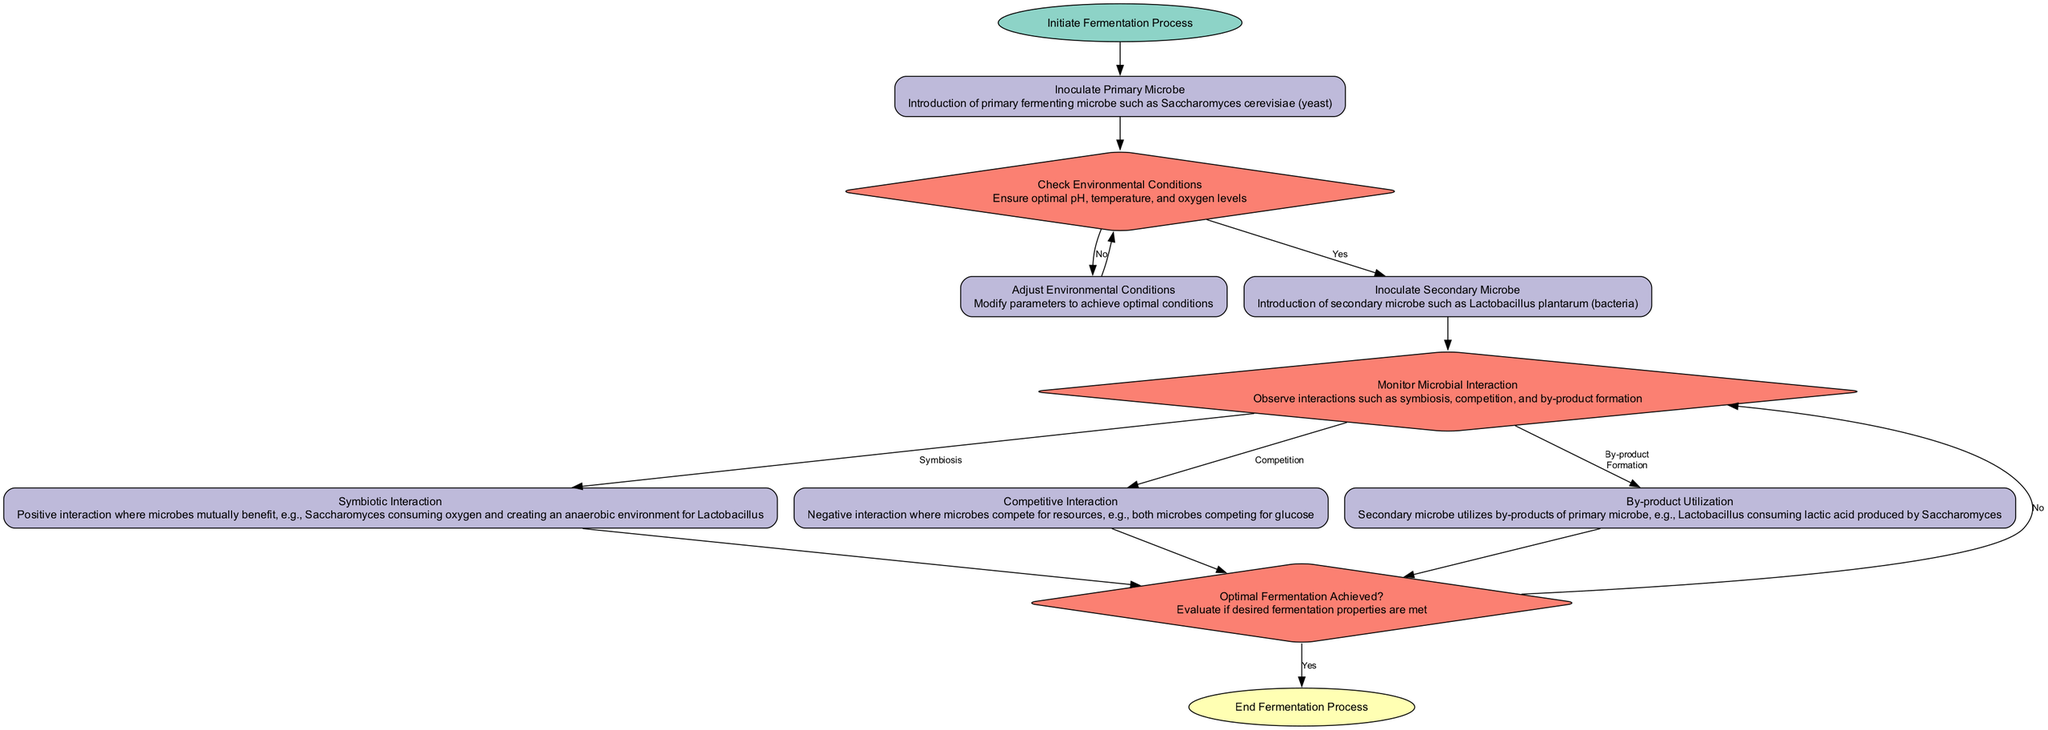What is the first step in the fermentation process? The diagram indicates that the fermentation process begins with the node titled "Initiate Fermentation Process," which serves as the starting point.
Answer: Initiate Fermentation Process How many decision points are in the diagram? By examining the diagram, there are three decision nodes: "Check Environmental Conditions," "Monitor Microbial Interaction," and "Optimal Fermentation Achieved?" Therefore, the total is three decision points.
Answer: 3 What type of interaction occurs during the positive interaction phase? According to the diagram, the positive interaction is specifically referred to as "Symbiotic Interaction," which indicates the nature of the positive relationships among microbial species involved in co-culture fermentation.
Answer: Symbiotic Interaction What follows after the "Inoculate Secondary Microbe"? The flow from the "Inoculate Secondary Microbe" leads to the next process: "Monitor Microbial Interaction," thus establishing a sequential relationship in the steps of fermentation.
Answer: Monitor Microbial Interaction If the environmental conditions are optimal, which step happens next? The diagram indicates that if the optimal environmental conditions are present, the next action taken is to "Inoculate Secondary Microbe," following after the "Check Environmental Conditions."
Answer: Inoculate Secondary Microbe What happens if the desired fermentation properties are not met? If the fermentation properties are not satisfactory, the diagram indicates that the process returns to "Monitor Microbial Interaction," implying that further observation of the interactions is necessary before proceeding.
Answer: Monitor Microbial Interaction What type of interaction occurs when microbes compete for resources? The diagram shows a specific process labeled "Competitive Interaction," which denotes the scenario where microbial species are engaging in competition for vital resources such as nutrients.
Answer: Competitive Interaction What is the final step in the fermentation process? The diagram concludes with the node titled "End Fermentation Process," which indicates the termination of the fermentation activity once the prior processes have been completed and conditions met.
Answer: End Fermentation Process How does the primary microbe help the secondary microbe? The diagram specifies that during "Symbiotic Interaction," the primary microbe, such as Saccharomyces cerevisiae, assists the secondary microbe by creating an anaerobic environment that is beneficial for the secondary species like Lactobacillus.
Answer: By creating an anaerobic environment 